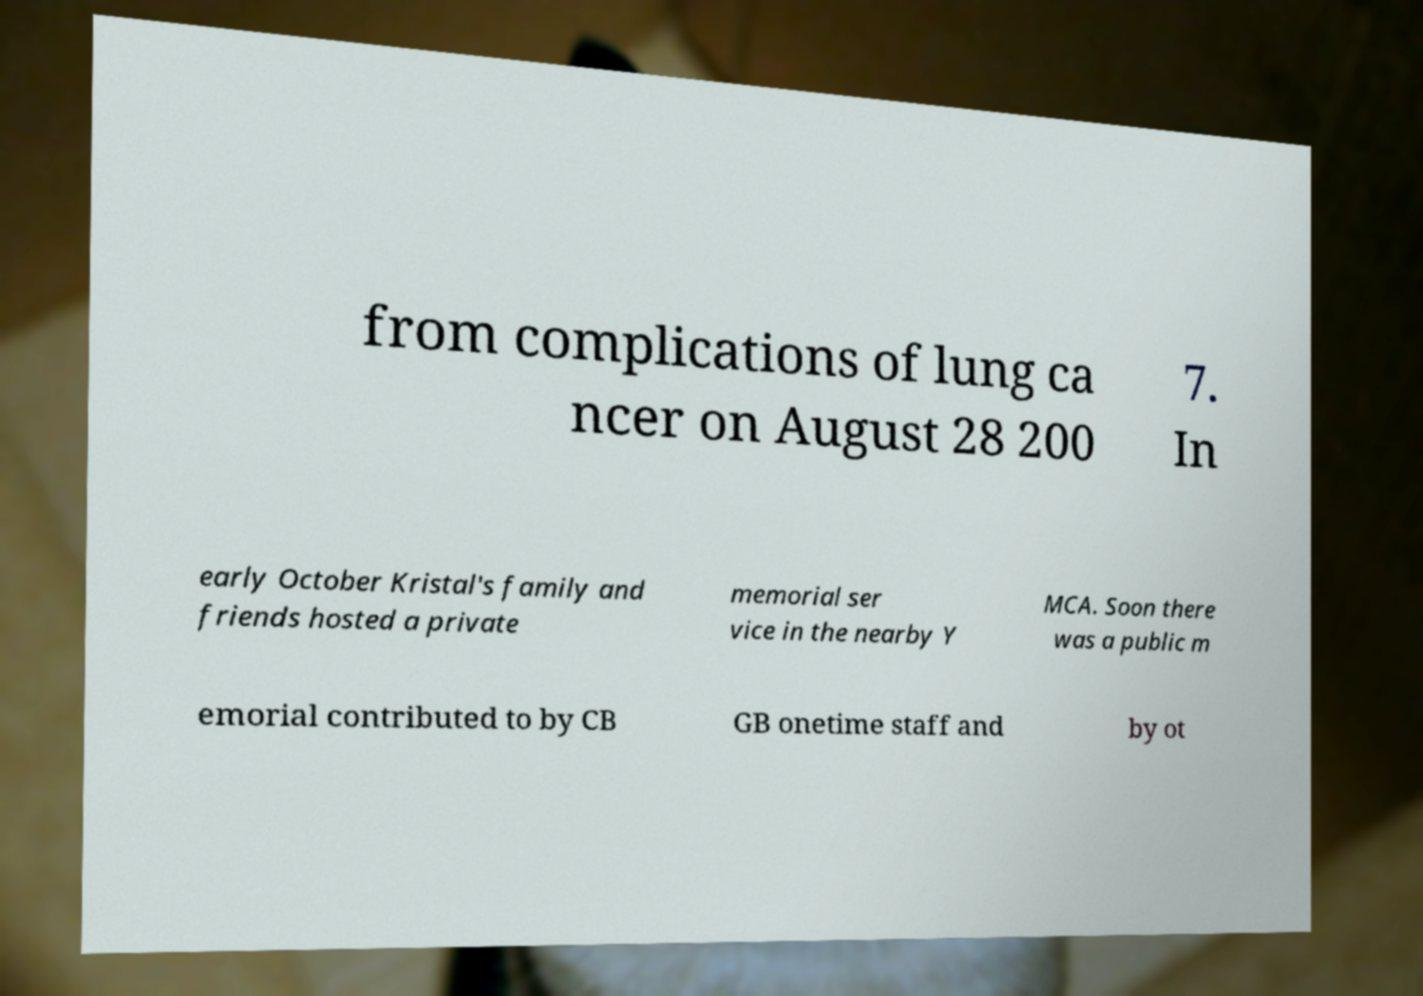Could you assist in decoding the text presented in this image and type it out clearly? from complications of lung ca ncer on August 28 200 7. In early October Kristal's family and friends hosted a private memorial ser vice in the nearby Y MCA. Soon there was a public m emorial contributed to by CB GB onetime staff and by ot 